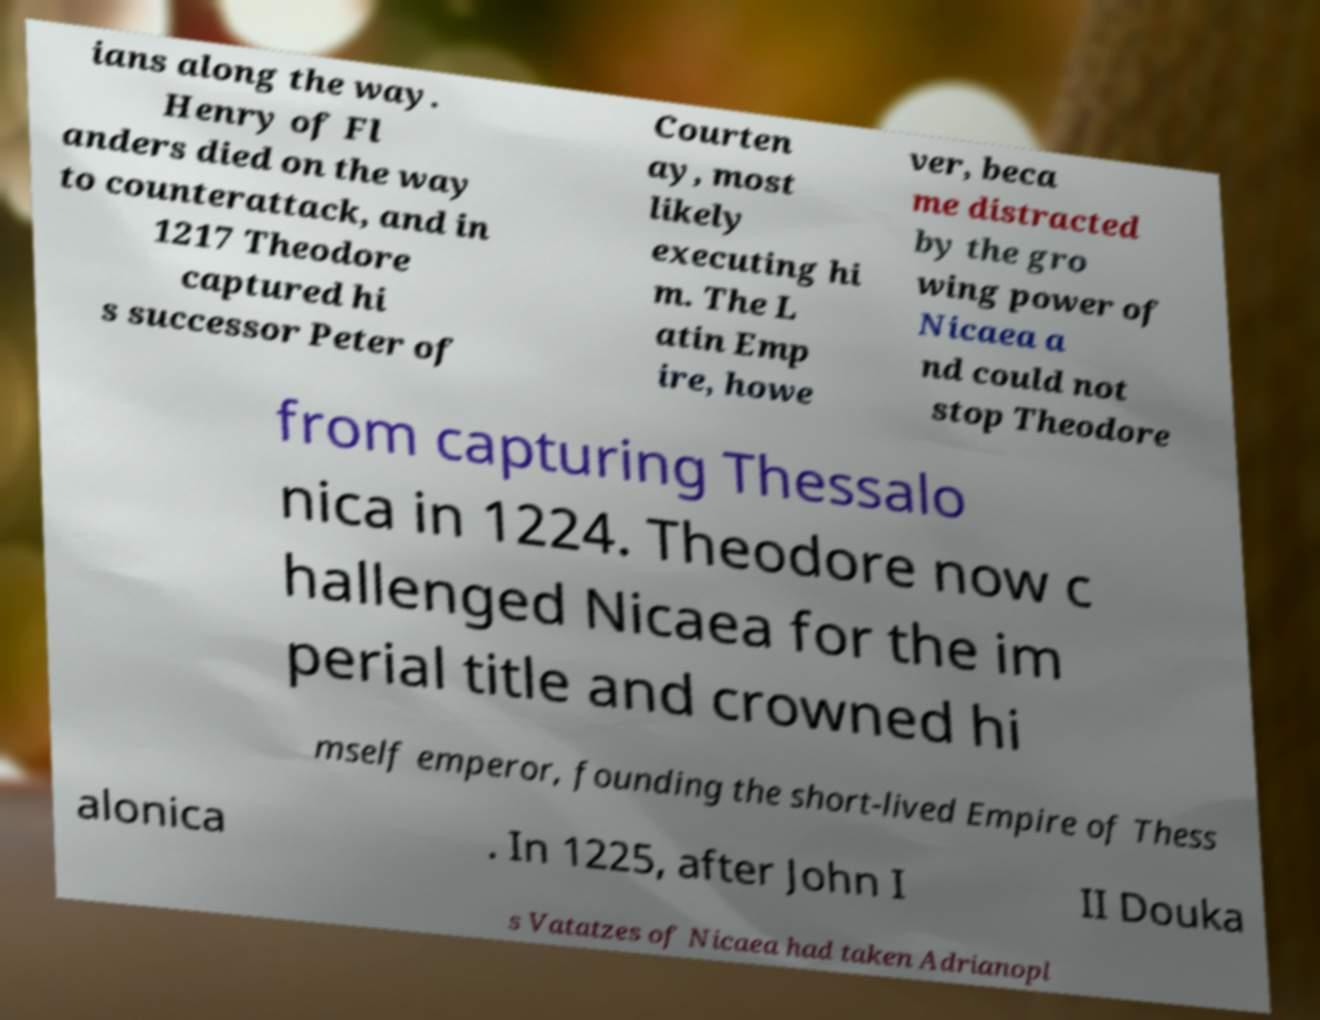Could you assist in decoding the text presented in this image and type it out clearly? ians along the way. Henry of Fl anders died on the way to counterattack, and in 1217 Theodore captured hi s successor Peter of Courten ay, most likely executing hi m. The L atin Emp ire, howe ver, beca me distracted by the gro wing power of Nicaea a nd could not stop Theodore from capturing Thessalo nica in 1224. Theodore now c hallenged Nicaea for the im perial title and crowned hi mself emperor, founding the short-lived Empire of Thess alonica . In 1225, after John I II Douka s Vatatzes of Nicaea had taken Adrianopl 